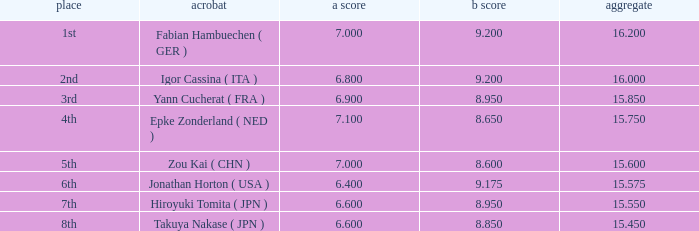What was the total rating that had a score higher than 7 and a b score smaller than 8.65? None. Can you parse all the data within this table? {'header': ['place', 'acrobat', 'a score', 'b score', 'aggregate'], 'rows': [['1st', 'Fabian Hambuechen ( GER )', '7.000', '9.200', '16.200'], ['2nd', 'Igor Cassina ( ITA )', '6.800', '9.200', '16.000'], ['3rd', 'Yann Cucherat ( FRA )', '6.900', '8.950', '15.850'], ['4th', 'Epke Zonderland ( NED )', '7.100', '8.650', '15.750'], ['5th', 'Zou Kai ( CHN )', '7.000', '8.600', '15.600'], ['6th', 'Jonathan Horton ( USA )', '6.400', '9.175', '15.575'], ['7th', 'Hiroyuki Tomita ( JPN )', '6.600', '8.950', '15.550'], ['8th', 'Takuya Nakase ( JPN )', '6.600', '8.850', '15.450']]} 